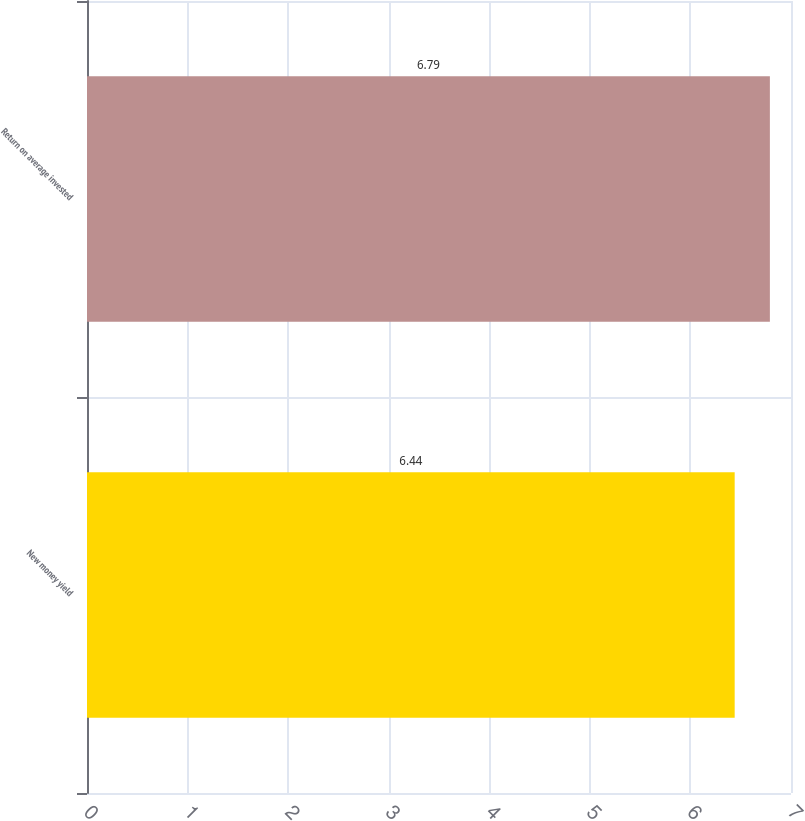Convert chart to OTSL. <chart><loc_0><loc_0><loc_500><loc_500><bar_chart><fcel>New money yield<fcel>Return on average invested<nl><fcel>6.44<fcel>6.79<nl></chart> 